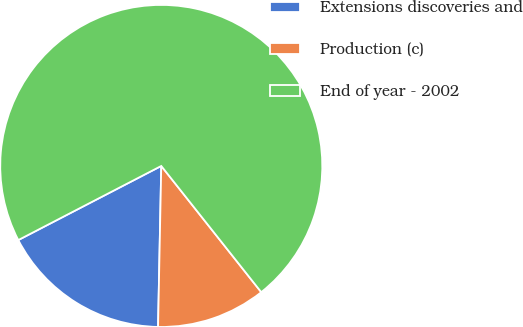Convert chart to OTSL. <chart><loc_0><loc_0><loc_500><loc_500><pie_chart><fcel>Extensions discoveries and<fcel>Production (c)<fcel>End of year - 2002<nl><fcel>17.07%<fcel>10.98%<fcel>71.95%<nl></chart> 